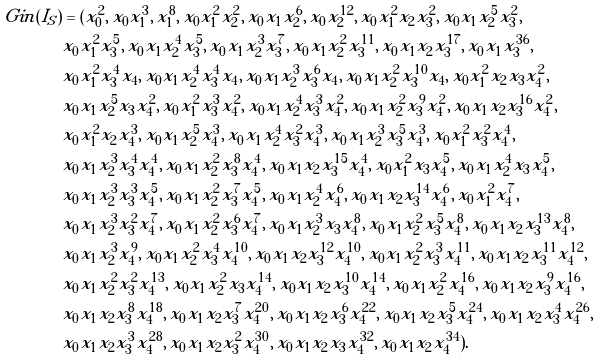Convert formula to latex. <formula><loc_0><loc_0><loc_500><loc_500>\ G i n ( I _ { S } ) & = ( x _ { 0 } ^ { 2 } , \, x _ { 0 } x _ { 1 } ^ { 3 } , \, x _ { 1 } ^ { 8 } , \, x _ { 0 } x _ { 1 } ^ { 2 } x _ { 2 } ^ { 2 } , \, x _ { 0 } x _ { 1 } x _ { 2 } ^ { 6 } , \, x _ { 0 } x _ { 2 } ^ { 1 2 } , \, x _ { 0 } x _ { 1 } ^ { 2 } x _ { 2 } x _ { 3 } ^ { 2 } , \, x _ { 0 } x _ { 1 } x _ { 2 } ^ { 5 } x _ { 3 } ^ { 2 } , \, \\ & x _ { 0 } x _ { 1 } ^ { 2 } x _ { 3 } ^ { 5 } , \, x _ { 0 } x _ { 1 } x _ { 2 } ^ { 4 } x _ { 3 } ^ { 5 } , \, x _ { 0 } x _ { 1 } x _ { 2 } ^ { 3 } x _ { 3 } ^ { 7 } , \, x _ { 0 } x _ { 1 } x _ { 2 } ^ { 2 } x _ { 3 } ^ { 1 1 } , \, x _ { 0 } x _ { 1 } x _ { 2 } x _ { 3 } ^ { 1 7 } , \, { x _ { 0 } x _ { 1 } x _ { 3 } ^ { 3 6 } } , \, \\ & x _ { 0 } x _ { 1 } ^ { 2 } x _ { 3 } ^ { 4 } x _ { 4 } , \, x _ { 0 } x _ { 1 } x _ { 2 } ^ { 4 } x _ { 3 } ^ { 4 } x _ { 4 } , \, x _ { 0 } x _ { 1 } x _ { 2 } ^ { 3 } x _ { 3 } ^ { 6 } x _ { 4 } , \, x _ { 0 } x _ { 1 } x _ { 2 } ^ { 2 } x _ { 3 } ^ { 1 0 } x _ { 4 } , \, x _ { 0 } x _ { 1 } ^ { 2 } x _ { 2 } x _ { 3 } x _ { 4 } ^ { 2 } , \, \\ & x _ { 0 } x _ { 1 } x _ { 2 } ^ { 5 } x _ { 3 } x _ { 4 } ^ { 2 } , \, x _ { 0 } x _ { 1 } ^ { 2 } x _ { 3 } ^ { 3 } x _ { 4 } ^ { 2 } , \, x _ { 0 } x _ { 1 } x _ { 2 } ^ { 4 } x _ { 3 } ^ { 3 } x _ { 4 } ^ { 2 } , \, x _ { 0 } x _ { 1 } x _ { 2 } ^ { 2 } x _ { 3 } ^ { 9 } x _ { 4 } ^ { 2 } , \, x _ { 0 } x _ { 1 } x _ { 2 } x _ { 3 } ^ { 1 6 } x _ { 4 } ^ { 2 } , \, \\ & x _ { 0 } x _ { 1 } ^ { 2 } x _ { 2 } x _ { 4 } ^ { 3 } , \, x _ { 0 } x _ { 1 } x _ { 2 } ^ { 5 } x _ { 4 } ^ { 3 } , \, x _ { 0 } x _ { 1 } x _ { 2 } ^ { 4 } x _ { 3 } ^ { 2 } x _ { 4 } ^ { 3 } , \, x _ { 0 } x _ { 1 } x _ { 2 } ^ { 3 } x _ { 3 } ^ { 5 } x _ { 4 } ^ { 3 } , \, x _ { 0 } x _ { 1 } ^ { 2 } x _ { 3 } ^ { 2 } x _ { 4 } ^ { 4 } , \, \\ & x _ { 0 } x _ { 1 } x _ { 2 } ^ { 3 } x _ { 3 } ^ { 4 } x _ { 4 } ^ { 4 } , \, x _ { 0 } x _ { 1 } x _ { 2 } ^ { 2 } x _ { 3 } ^ { 8 } x _ { 4 } ^ { 4 } , \, x _ { 0 } x _ { 1 } x _ { 2 } x _ { 3 } ^ { 1 5 } x _ { 4 } ^ { 4 } , \, x _ { 0 } x _ { 1 } ^ { 2 } x _ { 3 } x _ { 4 } ^ { 5 } , \, x _ { 0 } x _ { 1 } x _ { 2 } ^ { 4 } x _ { 3 } x _ { 4 } ^ { 5 } , \, \\ & x _ { 0 } x _ { 1 } x _ { 2 } ^ { 3 } x _ { 3 } ^ { 3 } x _ { 4 } ^ { 5 } , \, x _ { 0 } x _ { 1 } x _ { 2 } ^ { 2 } x _ { 3 } ^ { 7 } x _ { 4 } ^ { 5 } , \, x _ { 0 } x _ { 1 } x _ { 2 } ^ { 4 } x _ { 4 } ^ { 6 } , \, x _ { 0 } x _ { 1 } x _ { 2 } x _ { 3 } ^ { 1 4 } x _ { 4 } ^ { 6 } , \, x _ { 0 } x _ { 1 } ^ { 2 } x _ { 4 } ^ { 7 } , \, \\ & x _ { 0 } x _ { 1 } x _ { 2 } ^ { 3 } x _ { 3 } ^ { 2 } x _ { 4 } ^ { 7 } , \, x _ { 0 } x _ { 1 } x _ { 2 } ^ { 2 } x _ { 3 } ^ { 6 } x _ { 4 } ^ { 7 } , \, x _ { 0 } x _ { 1 } x _ { 2 } ^ { 3 } x _ { 3 } x _ { 4 } ^ { 8 } , \, x _ { 0 } x _ { 1 } x _ { 2 } ^ { 2 } x _ { 3 } ^ { 5 } x _ { 4 } ^ { 8 } , \, x _ { 0 } x _ { 1 } x _ { 2 } x _ { 3 } ^ { 1 3 } x _ { 4 } ^ { 8 } , \, \\ & x _ { 0 } x _ { 1 } x _ { 2 } ^ { 3 } x _ { 4 } ^ { 9 } , \, x _ { 0 } x _ { 1 } x _ { 2 } ^ { 2 } x _ { 3 } ^ { 4 } x _ { 4 } ^ { 1 0 } , \, x _ { 0 } x _ { 1 } x _ { 2 } x _ { 3 } ^ { 1 2 } x _ { 4 } ^ { 1 0 } , \, x _ { 0 } x _ { 1 } x _ { 2 } ^ { 2 } x _ { 3 } ^ { 3 } x _ { 4 } ^ { 1 1 } , \, x _ { 0 } x _ { 1 } x _ { 2 } x _ { 3 } ^ { 1 1 } x _ { 4 } ^ { 1 2 } , \, \\ & x _ { 0 } x _ { 1 } x _ { 2 } ^ { 2 } x _ { 3 } ^ { 2 } x _ { 4 } ^ { 1 3 } , \, x _ { 0 } x _ { 1 } x _ { 2 } ^ { 2 } x _ { 3 } x _ { 4 } ^ { 1 4 } , \, x _ { 0 } x _ { 1 } x _ { 2 } x _ { 3 } ^ { 1 0 } x _ { 4 } ^ { 1 4 } , \, x _ { 0 } x _ { 1 } x _ { 2 } ^ { 2 } x _ { 4 } ^ { 1 6 } , \, x _ { 0 } x _ { 1 } x _ { 2 } x _ { 3 } ^ { 9 } x _ { 4 } ^ { 1 6 } , \, \\ & x _ { 0 } x _ { 1 } x _ { 2 } x _ { 3 } ^ { 8 } x _ { 4 } ^ { 1 8 } , \, x _ { 0 } x _ { 1 } x _ { 2 } x _ { 3 } ^ { 7 } x _ { 4 } ^ { 2 0 } , \, x _ { 0 } x _ { 1 } x _ { 2 } x _ { 3 } ^ { 6 } x _ { 4 } ^ { 2 2 } , \, x _ { 0 } x _ { 1 } x _ { 2 } x _ { 3 } ^ { 5 } x _ { 4 } ^ { 2 4 } , \, x _ { 0 } x _ { 1 } x _ { 2 } x _ { 3 } ^ { 4 } x _ { 4 } ^ { 2 6 } , \, \\ & x _ { 0 } x _ { 1 } x _ { 2 } x _ { 3 } ^ { 3 } x _ { 4 } ^ { 2 8 } , \, x _ { 0 } x _ { 1 } x _ { 2 } x _ { 3 } ^ { 2 } x _ { 4 } ^ { 3 0 } , \, x _ { 0 } x _ { 1 } x _ { 2 } x _ { 3 } x _ { 4 } ^ { 3 2 } , \, x _ { 0 } x _ { 1 } x _ { 2 } x _ { 4 } ^ { 3 4 } ) .</formula> 